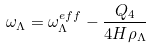Convert formula to latex. <formula><loc_0><loc_0><loc_500><loc_500>\omega _ { \Lambda } = \omega ^ { e f f } _ { \Lambda } - \frac { Q _ { 4 } } { 4 H \rho _ { \Lambda } }</formula> 